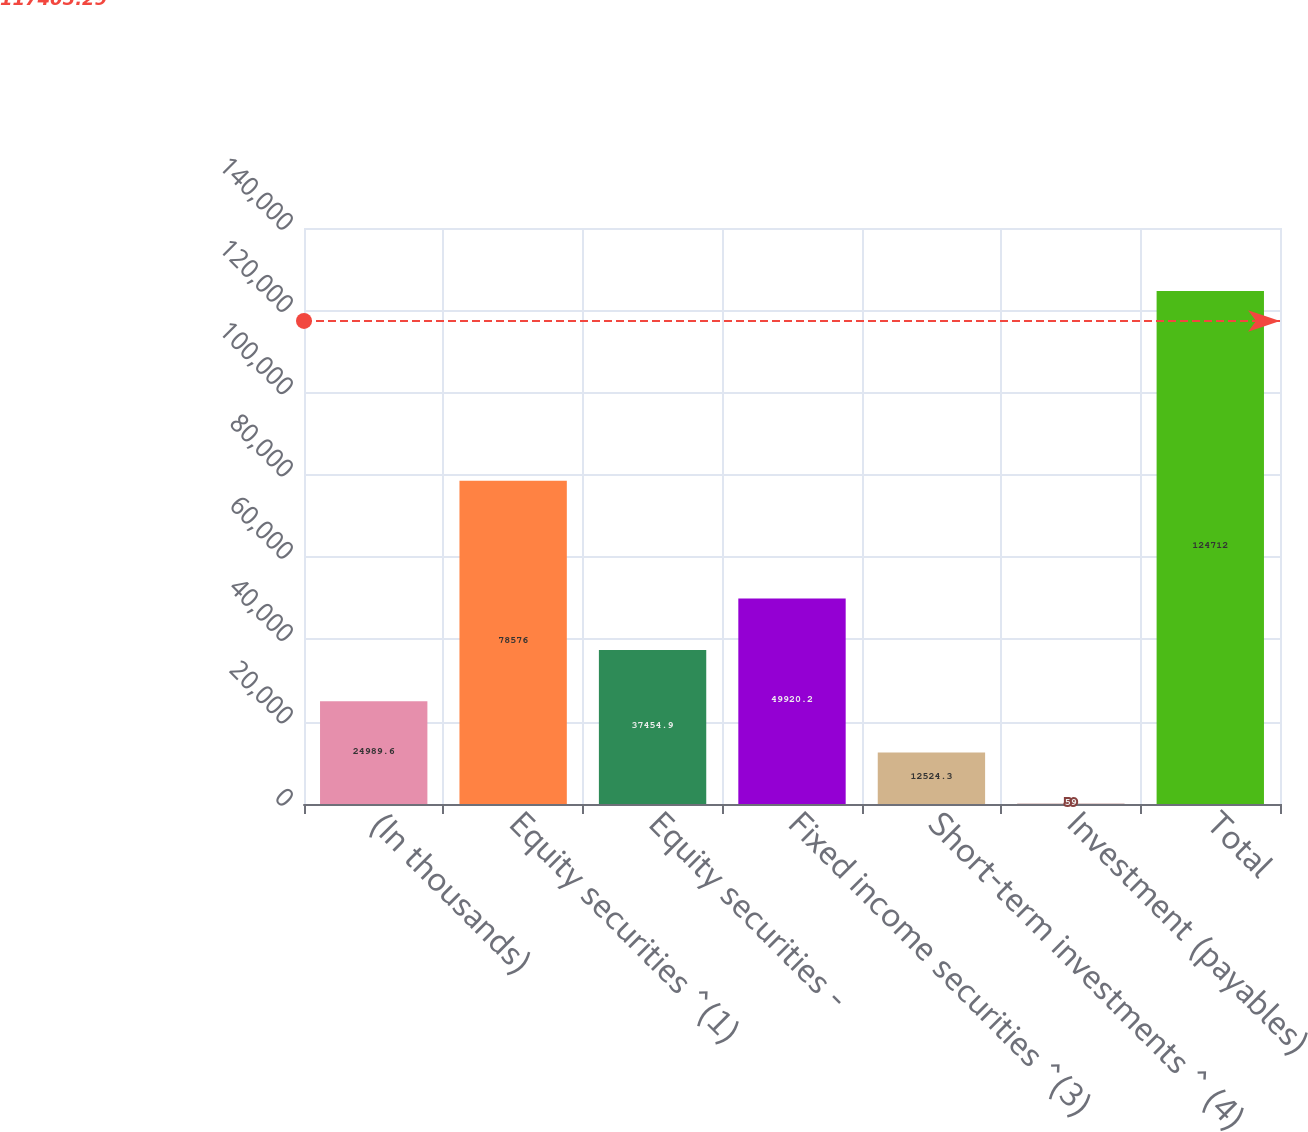<chart> <loc_0><loc_0><loc_500><loc_500><bar_chart><fcel>(In thousands)<fcel>Equity securities ^(1)<fcel>Equity securities -<fcel>Fixed income securities ^(3)<fcel>Short-term investments ^ (4)<fcel>Investment (payables)<fcel>Total<nl><fcel>24989.6<fcel>78576<fcel>37454.9<fcel>49920.2<fcel>12524.3<fcel>59<fcel>124712<nl></chart> 